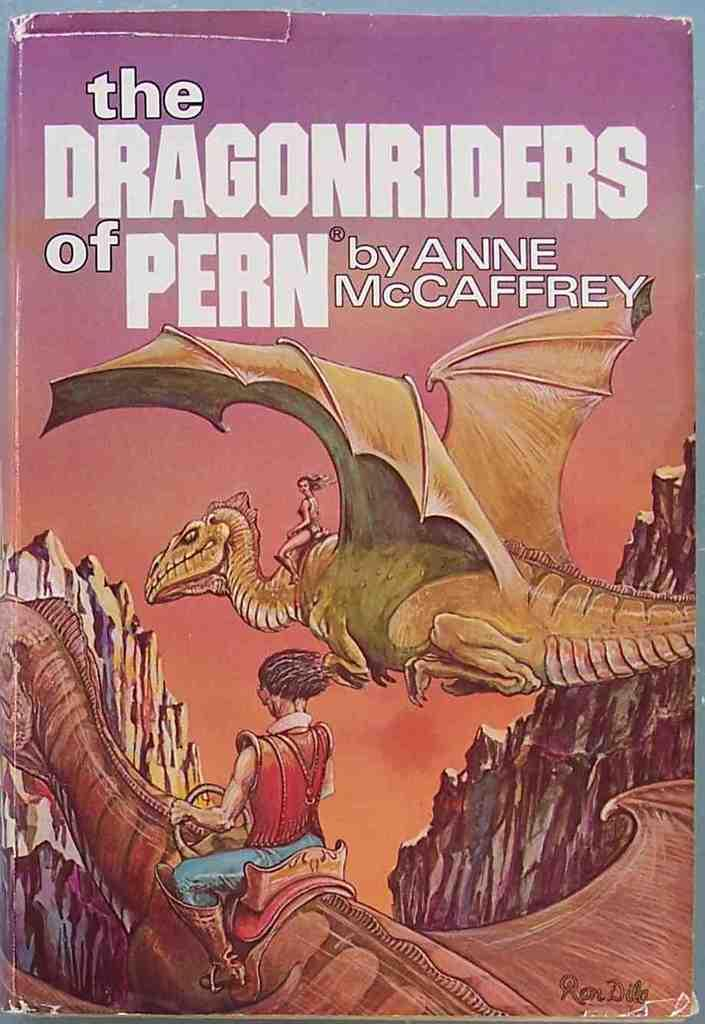<image>
Give a short and clear explanation of the subsequent image. The Dragonriders of Pern is the title of this science fiction, paper back book. 